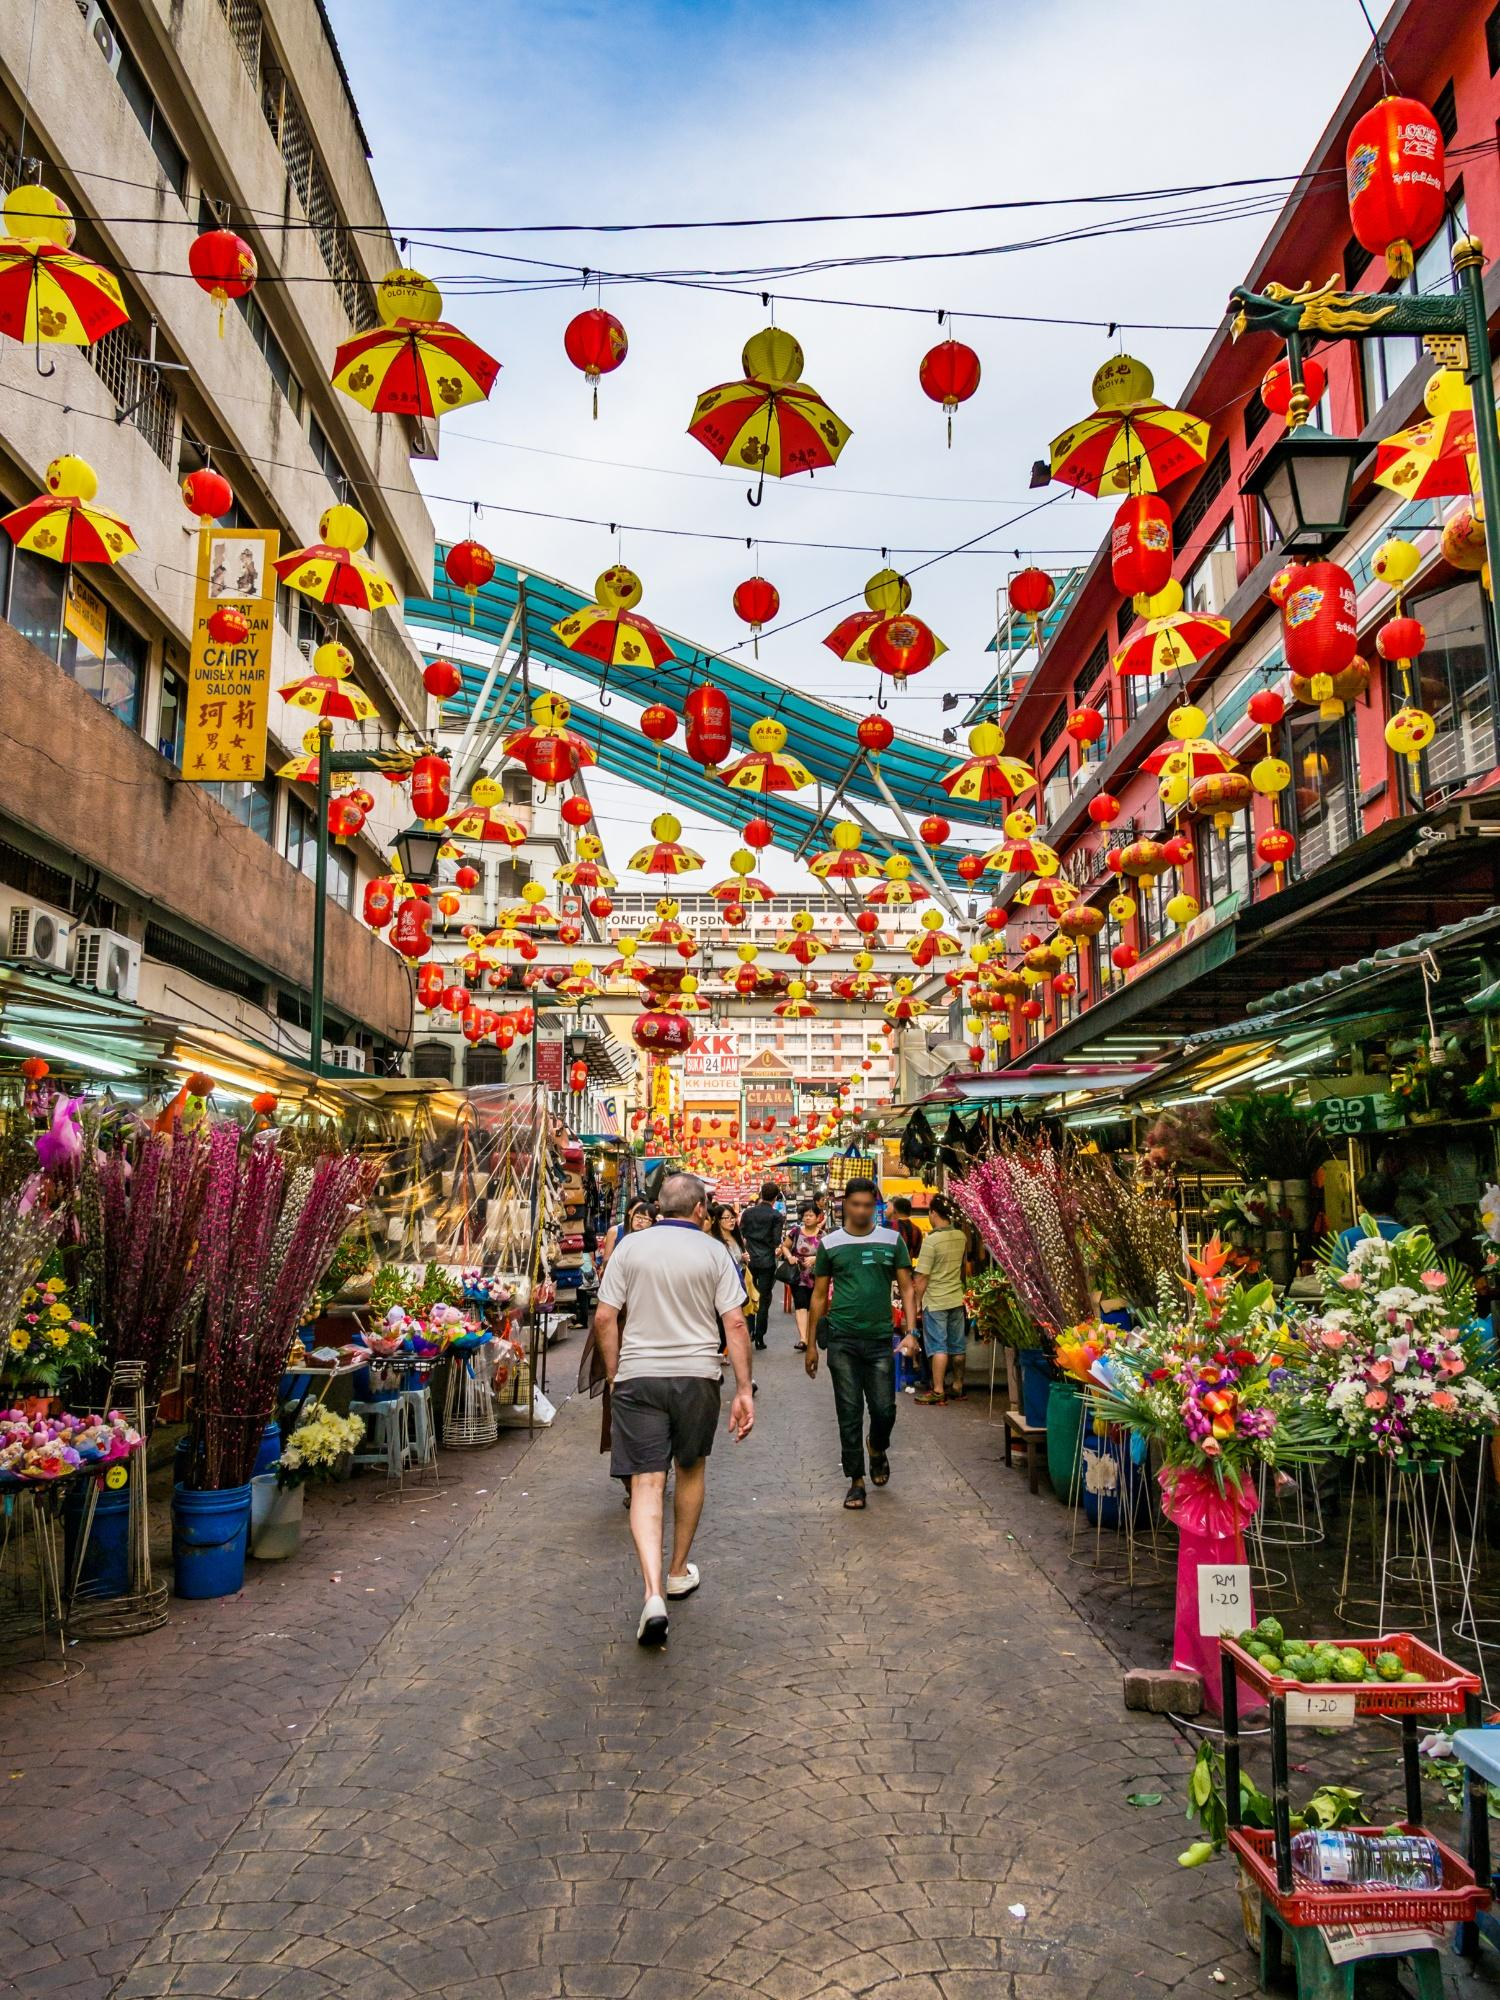Imagine how this scene transforms at night. At night, this street in Bangkok's Chinatown transforms into an even more magical scene. The overhead lanterns and umbrellas, already delightful by day, are illuminated by soft, warm lights, casting a golden glow that bathes the entire street. The bustling activity of the day is replaced by a different kind of vibrancy—street food vendors set up their stalls, the aromas of various delicacies wafting through the air and mingling with the sounds of sizzling pans and jovial chatter.

Neon signs flicker into life, their bright hues reflecting off of the market stalls below, each light a beacon calling patrons to enjoy the evening's offerings. The crowd shifts as locals and tourists alike come out to enjoy the cooler evening air, exploring food stalls, purchasing handmade trinkets, and engaging in casual conversations under the mesmerizing lantern-lit canopy. The entire street exudes a festive, communal atmosphere, making night-time in Bangkok's Chinatown a captivating experience of sights, sounds, and tastes. 